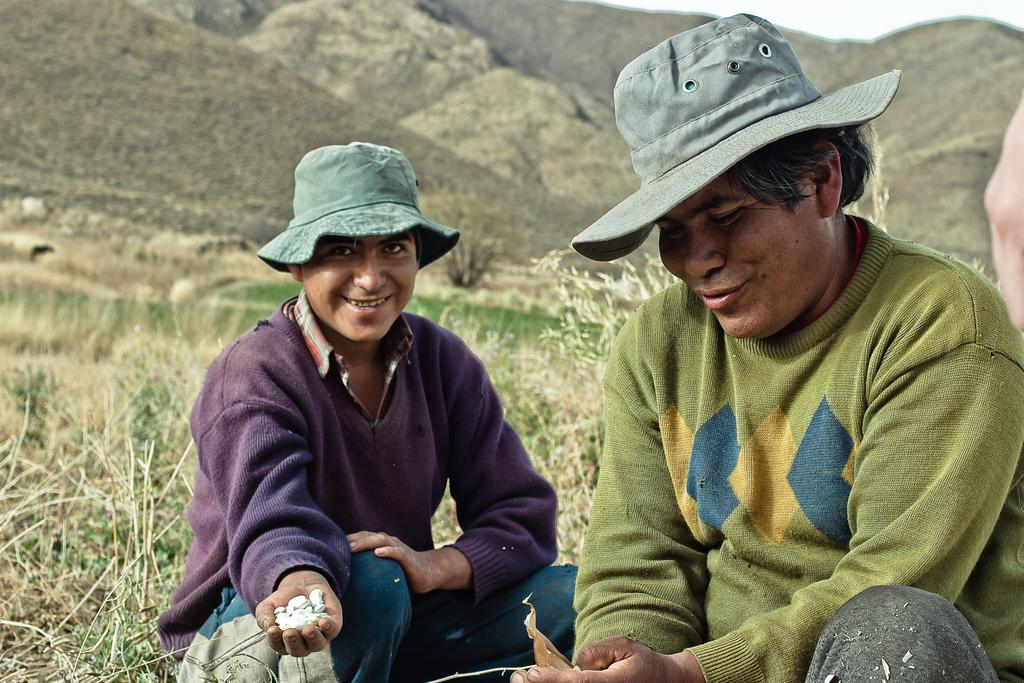How many people are in the image? There are two men in the image. What are the men wearing on their heads? Both men are wearing caps. What expression do the men have on their faces? Both men are smiling. What is in the hand of one of the men? There are objects in the hand of one of the men. What can be seen in the background of the image? There is grass, plants, and mountains in the background of the image. Can you see the ocean in the background of the image? No, there is no ocean visible in the image; the background features grass, plants, and mountains. What type of thoughts are the men having in the image? The provided facts do not give any information about the men's thoughts or mental state, so it cannot be determined from the image. 